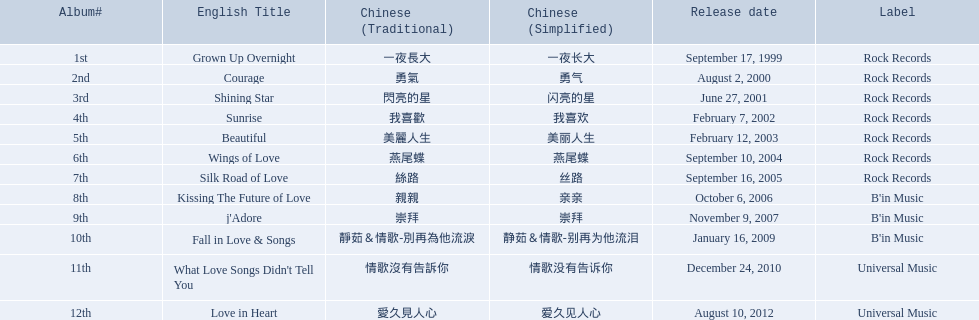What albums were there? Grown Up Overnight, Courage, Shining Star, Sunrise, Beautiful, Wings of Love, Silk Road of Love, Kissing The Future of Love, j'Adore, Fall in Love & Songs, What Love Songs Didn't Tell You, Love in Heart. Which ones were put out by b'in music? Kissing The Future of Love, j'Adore. Out of those, which one was released in an even-numbered year? Kissing The Future of Love. 